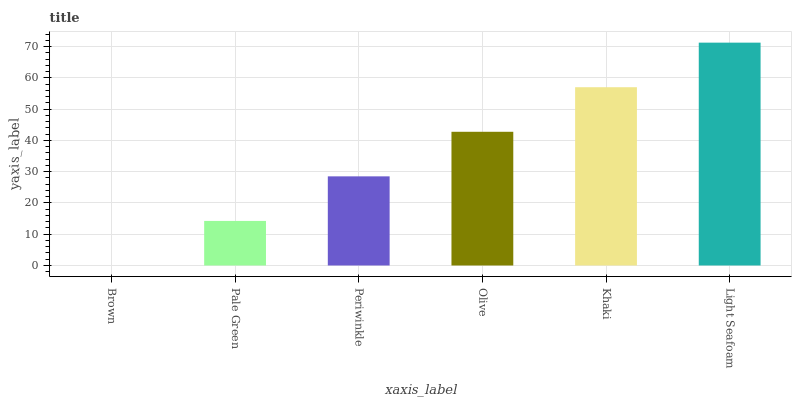Is Brown the minimum?
Answer yes or no. Yes. Is Light Seafoam the maximum?
Answer yes or no. Yes. Is Pale Green the minimum?
Answer yes or no. No. Is Pale Green the maximum?
Answer yes or no. No. Is Pale Green greater than Brown?
Answer yes or no. Yes. Is Brown less than Pale Green?
Answer yes or no. Yes. Is Brown greater than Pale Green?
Answer yes or no. No. Is Pale Green less than Brown?
Answer yes or no. No. Is Olive the high median?
Answer yes or no. Yes. Is Periwinkle the low median?
Answer yes or no. Yes. Is Light Seafoam the high median?
Answer yes or no. No. Is Khaki the low median?
Answer yes or no. No. 